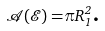<formula> <loc_0><loc_0><loc_500><loc_500>\mathcal { A } ( \mathcal { E ) = } \pi R _ { 1 } ^ { 2 } \text {.}</formula> 